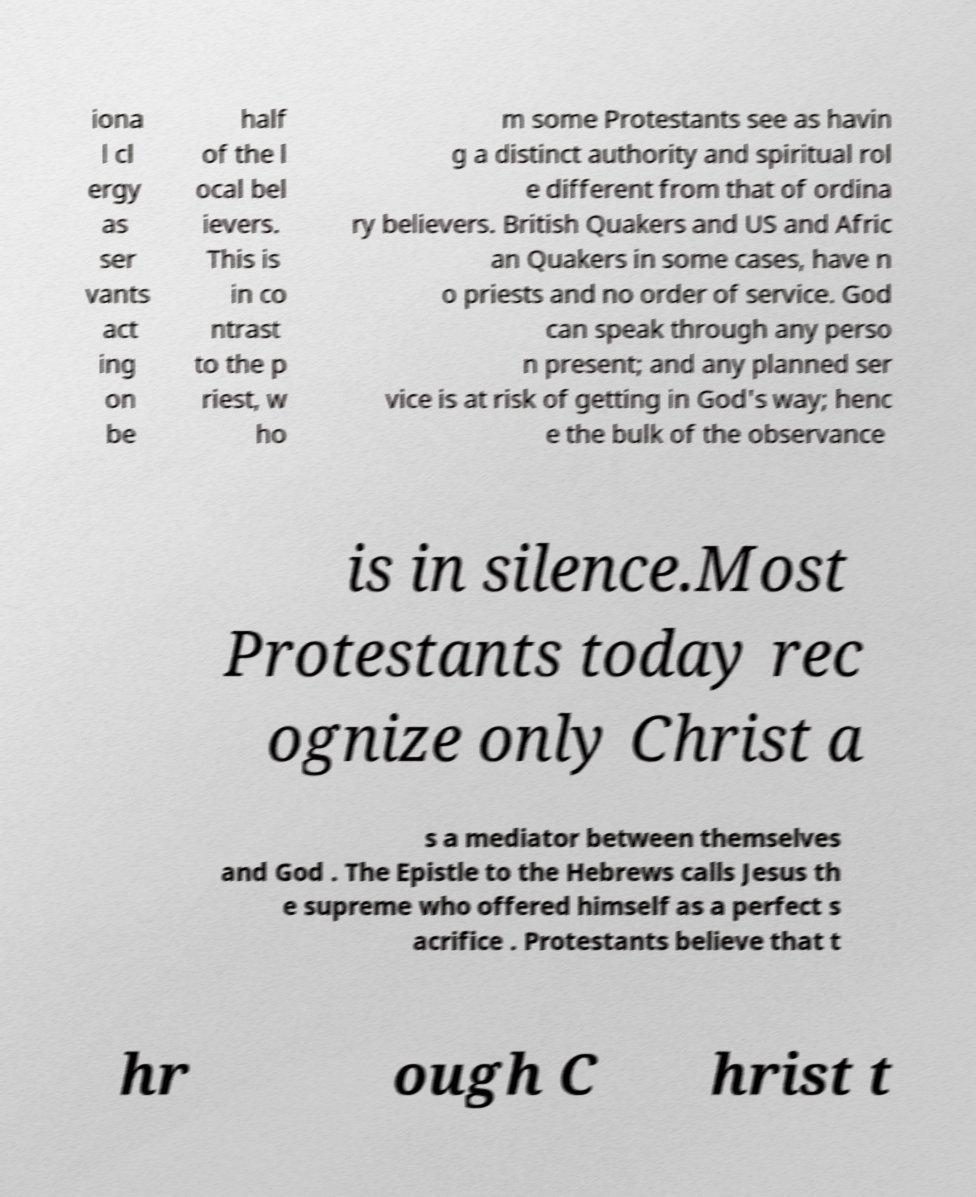For documentation purposes, I need the text within this image transcribed. Could you provide that? iona l cl ergy as ser vants act ing on be half of the l ocal bel ievers. This is in co ntrast to the p riest, w ho m some Protestants see as havin g a distinct authority and spiritual rol e different from that of ordina ry believers. British Quakers and US and Afric an Quakers in some cases, have n o priests and no order of service. God can speak through any perso n present; and any planned ser vice is at risk of getting in God's way; henc e the bulk of the observance is in silence.Most Protestants today rec ognize only Christ a s a mediator between themselves and God . The Epistle to the Hebrews calls Jesus th e supreme who offered himself as a perfect s acrifice . Protestants believe that t hr ough C hrist t 